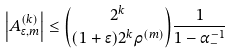Convert formula to latex. <formula><loc_0><loc_0><loc_500><loc_500>\left | A _ { \epsilon , m } ^ { ( k ) } \right | \leq { 2 ^ { k } \choose ( 1 + \epsilon ) 2 ^ { k } \rho ^ { ( m ) } } \frac { 1 } { 1 - \alpha _ { - } ^ { - 1 } }</formula> 